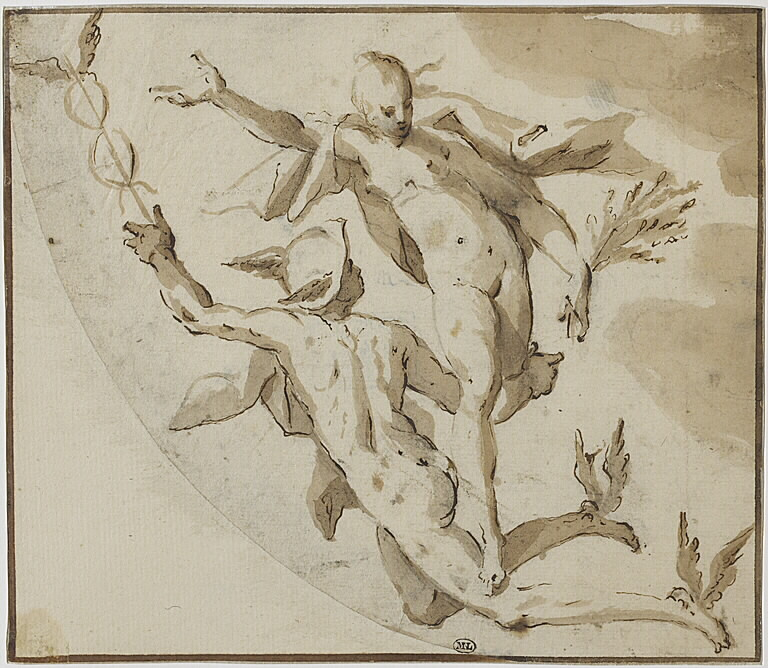What details can you observe in the composition and style of this artwork? The artwork is rich in detail and movement. The figures are engaged in a dynamic interaction that is both fluid and dramatic. The use of washes of gray and brown adds depth and texture to the scene. The circular composition not only frames the figures but also directs the viewer's eye around the scene, enhancing the sense of motion. The sketchy nature of the artwork suggests it may be a preliminary study for a larger, more detailed piece. 